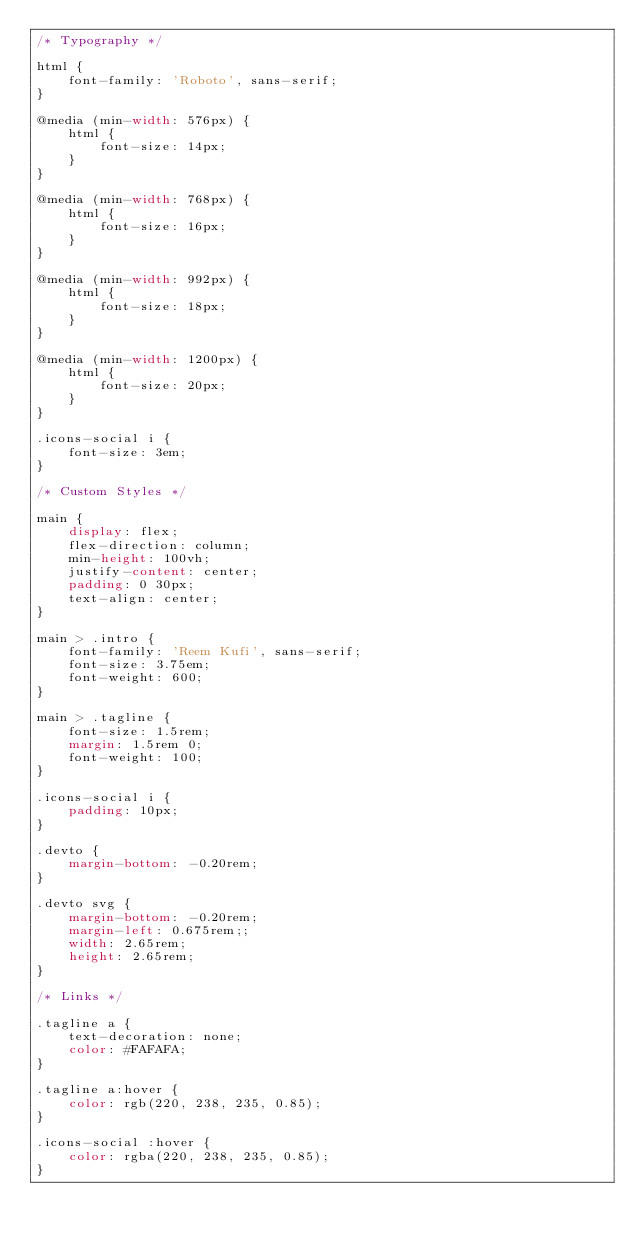Convert code to text. <code><loc_0><loc_0><loc_500><loc_500><_CSS_>/* Typography */

html {
	font-family: 'Roboto', sans-serif;
}

@media (min-width: 576px) {
	html {
		font-size: 14px;
	}
}

@media (min-width: 768px) {
	html {
		font-size: 16px;
	}
}

@media (min-width: 992px) {
	html {
		font-size: 18px;
	}
}

@media (min-width: 1200px) {
	html {
		font-size: 20px;
	}
}

.icons-social i {
	font-size: 3em;
}

/* Custom Styles */

main {
	display: flex;
	flex-direction: column;
	min-height: 100vh;
	justify-content: center;
	padding: 0 30px;
	text-align: center;
}

main > .intro {
	font-family: 'Reem Kufi', sans-serif;
	font-size: 3.75em;
	font-weight: 600;
}

main > .tagline {
	font-size: 1.5rem;
	margin: 1.5rem 0;
	font-weight: 100;
}

.icons-social i {
	padding: 10px;
}

.devto {
	margin-bottom: -0.20rem;
}

.devto svg {
	margin-bottom: -0.20rem;
	margin-left: 0.675rem;;
	width: 2.65rem;
	height: 2.65rem;
}

/* Links */

.tagline a {
	text-decoration: none;
	color: #FAFAFA;
}

.tagline a:hover {
	color: rgb(220, 238, 235, 0.85);
}

.icons-social :hover {
	color: rgba(220, 238, 235, 0.85);
}</code> 